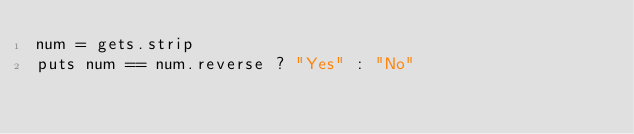Convert code to text. <code><loc_0><loc_0><loc_500><loc_500><_Ruby_>num = gets.strip
puts num == num.reverse ? "Yes" : "No"
</code> 